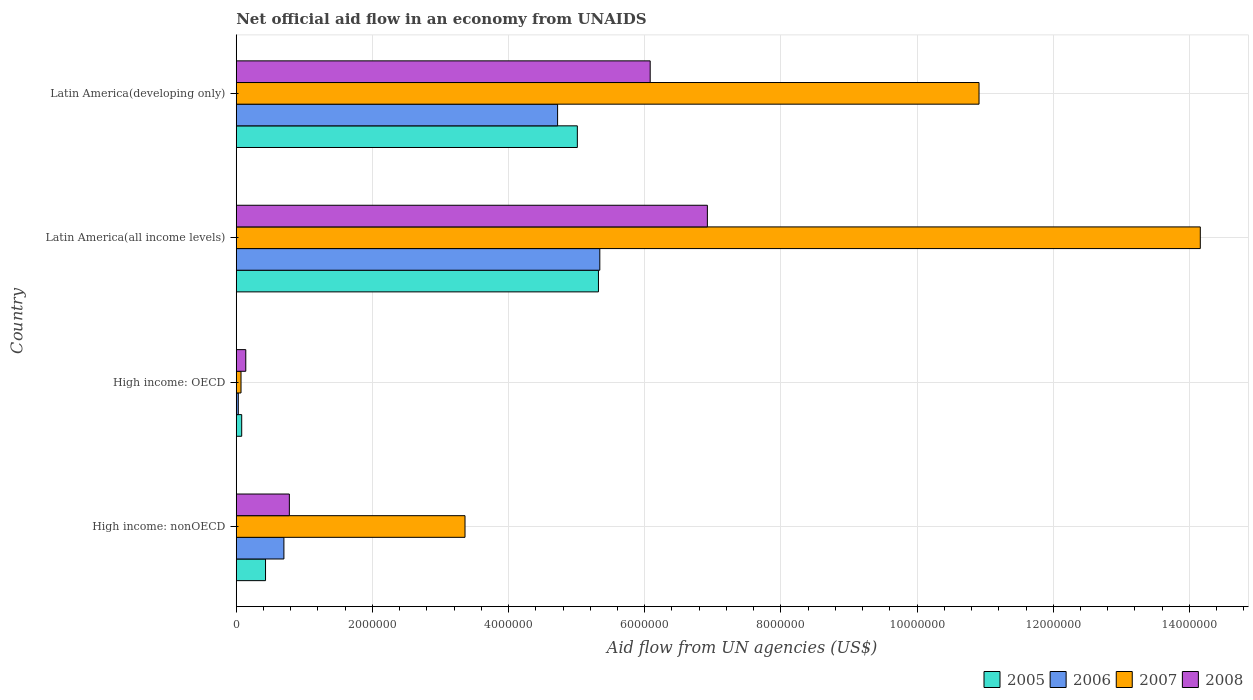Are the number of bars on each tick of the Y-axis equal?
Your answer should be very brief. Yes. What is the label of the 2nd group of bars from the top?
Ensure brevity in your answer.  Latin America(all income levels). In how many cases, is the number of bars for a given country not equal to the number of legend labels?
Your answer should be very brief. 0. What is the net official aid flow in 2008 in High income: nonOECD?
Offer a very short reply. 7.80e+05. Across all countries, what is the maximum net official aid flow in 2005?
Give a very brief answer. 5.32e+06. In which country was the net official aid flow in 2005 maximum?
Your response must be concise. Latin America(all income levels). In which country was the net official aid flow in 2005 minimum?
Ensure brevity in your answer.  High income: OECD. What is the total net official aid flow in 2007 in the graph?
Ensure brevity in your answer.  2.85e+07. What is the difference between the net official aid flow in 2005 in Latin America(all income levels) and that in Latin America(developing only)?
Make the answer very short. 3.10e+05. What is the difference between the net official aid flow in 2008 in Latin America(developing only) and the net official aid flow in 2006 in High income: nonOECD?
Give a very brief answer. 5.38e+06. What is the average net official aid flow in 2007 per country?
Keep it short and to the point. 7.12e+06. What is the difference between the net official aid flow in 2006 and net official aid flow in 2007 in Latin America(developing only)?
Your response must be concise. -6.19e+06. In how many countries, is the net official aid flow in 2008 greater than 2800000 US$?
Give a very brief answer. 2. What is the ratio of the net official aid flow in 2005 in High income: nonOECD to that in Latin America(developing only)?
Keep it short and to the point. 0.09. Is the net official aid flow in 2006 in High income: OECD less than that in High income: nonOECD?
Provide a succinct answer. Yes. What is the difference between the highest and the second highest net official aid flow in 2008?
Make the answer very short. 8.40e+05. What is the difference between the highest and the lowest net official aid flow in 2008?
Your answer should be compact. 6.78e+06. What does the 4th bar from the bottom in High income: OECD represents?
Your answer should be very brief. 2008. Is it the case that in every country, the sum of the net official aid flow in 2005 and net official aid flow in 2006 is greater than the net official aid flow in 2007?
Offer a terse response. No. How many bars are there?
Your response must be concise. 16. Are all the bars in the graph horizontal?
Offer a very short reply. Yes. How many countries are there in the graph?
Offer a terse response. 4. What is the difference between two consecutive major ticks on the X-axis?
Offer a terse response. 2.00e+06. Does the graph contain any zero values?
Your answer should be compact. No. How many legend labels are there?
Keep it short and to the point. 4. How are the legend labels stacked?
Your answer should be very brief. Horizontal. What is the title of the graph?
Provide a short and direct response. Net official aid flow in an economy from UNAIDS. Does "1995" appear as one of the legend labels in the graph?
Your answer should be compact. No. What is the label or title of the X-axis?
Provide a short and direct response. Aid flow from UN agencies (US$). What is the label or title of the Y-axis?
Provide a succinct answer. Country. What is the Aid flow from UN agencies (US$) in 2005 in High income: nonOECD?
Ensure brevity in your answer.  4.30e+05. What is the Aid flow from UN agencies (US$) in 2007 in High income: nonOECD?
Give a very brief answer. 3.36e+06. What is the Aid flow from UN agencies (US$) of 2008 in High income: nonOECD?
Provide a succinct answer. 7.80e+05. What is the Aid flow from UN agencies (US$) of 2008 in High income: OECD?
Offer a very short reply. 1.40e+05. What is the Aid flow from UN agencies (US$) in 2005 in Latin America(all income levels)?
Provide a short and direct response. 5.32e+06. What is the Aid flow from UN agencies (US$) in 2006 in Latin America(all income levels)?
Ensure brevity in your answer.  5.34e+06. What is the Aid flow from UN agencies (US$) in 2007 in Latin America(all income levels)?
Offer a terse response. 1.42e+07. What is the Aid flow from UN agencies (US$) in 2008 in Latin America(all income levels)?
Make the answer very short. 6.92e+06. What is the Aid flow from UN agencies (US$) of 2005 in Latin America(developing only)?
Your answer should be very brief. 5.01e+06. What is the Aid flow from UN agencies (US$) in 2006 in Latin America(developing only)?
Offer a terse response. 4.72e+06. What is the Aid flow from UN agencies (US$) of 2007 in Latin America(developing only)?
Your response must be concise. 1.09e+07. What is the Aid flow from UN agencies (US$) of 2008 in Latin America(developing only)?
Your answer should be very brief. 6.08e+06. Across all countries, what is the maximum Aid flow from UN agencies (US$) of 2005?
Your response must be concise. 5.32e+06. Across all countries, what is the maximum Aid flow from UN agencies (US$) in 2006?
Your answer should be very brief. 5.34e+06. Across all countries, what is the maximum Aid flow from UN agencies (US$) in 2007?
Give a very brief answer. 1.42e+07. Across all countries, what is the maximum Aid flow from UN agencies (US$) of 2008?
Give a very brief answer. 6.92e+06. Across all countries, what is the minimum Aid flow from UN agencies (US$) in 2005?
Ensure brevity in your answer.  8.00e+04. Across all countries, what is the minimum Aid flow from UN agencies (US$) in 2008?
Keep it short and to the point. 1.40e+05. What is the total Aid flow from UN agencies (US$) of 2005 in the graph?
Your answer should be very brief. 1.08e+07. What is the total Aid flow from UN agencies (US$) in 2006 in the graph?
Provide a succinct answer. 1.08e+07. What is the total Aid flow from UN agencies (US$) in 2007 in the graph?
Your answer should be very brief. 2.85e+07. What is the total Aid flow from UN agencies (US$) of 2008 in the graph?
Provide a succinct answer. 1.39e+07. What is the difference between the Aid flow from UN agencies (US$) of 2005 in High income: nonOECD and that in High income: OECD?
Provide a succinct answer. 3.50e+05. What is the difference between the Aid flow from UN agencies (US$) of 2006 in High income: nonOECD and that in High income: OECD?
Your response must be concise. 6.70e+05. What is the difference between the Aid flow from UN agencies (US$) of 2007 in High income: nonOECD and that in High income: OECD?
Give a very brief answer. 3.29e+06. What is the difference between the Aid flow from UN agencies (US$) of 2008 in High income: nonOECD and that in High income: OECD?
Keep it short and to the point. 6.40e+05. What is the difference between the Aid flow from UN agencies (US$) of 2005 in High income: nonOECD and that in Latin America(all income levels)?
Your response must be concise. -4.89e+06. What is the difference between the Aid flow from UN agencies (US$) in 2006 in High income: nonOECD and that in Latin America(all income levels)?
Your response must be concise. -4.64e+06. What is the difference between the Aid flow from UN agencies (US$) in 2007 in High income: nonOECD and that in Latin America(all income levels)?
Provide a short and direct response. -1.08e+07. What is the difference between the Aid flow from UN agencies (US$) of 2008 in High income: nonOECD and that in Latin America(all income levels)?
Give a very brief answer. -6.14e+06. What is the difference between the Aid flow from UN agencies (US$) of 2005 in High income: nonOECD and that in Latin America(developing only)?
Give a very brief answer. -4.58e+06. What is the difference between the Aid flow from UN agencies (US$) of 2006 in High income: nonOECD and that in Latin America(developing only)?
Keep it short and to the point. -4.02e+06. What is the difference between the Aid flow from UN agencies (US$) in 2007 in High income: nonOECD and that in Latin America(developing only)?
Offer a very short reply. -7.55e+06. What is the difference between the Aid flow from UN agencies (US$) of 2008 in High income: nonOECD and that in Latin America(developing only)?
Provide a succinct answer. -5.30e+06. What is the difference between the Aid flow from UN agencies (US$) in 2005 in High income: OECD and that in Latin America(all income levels)?
Ensure brevity in your answer.  -5.24e+06. What is the difference between the Aid flow from UN agencies (US$) in 2006 in High income: OECD and that in Latin America(all income levels)?
Make the answer very short. -5.31e+06. What is the difference between the Aid flow from UN agencies (US$) of 2007 in High income: OECD and that in Latin America(all income levels)?
Offer a terse response. -1.41e+07. What is the difference between the Aid flow from UN agencies (US$) in 2008 in High income: OECD and that in Latin America(all income levels)?
Your answer should be compact. -6.78e+06. What is the difference between the Aid flow from UN agencies (US$) in 2005 in High income: OECD and that in Latin America(developing only)?
Make the answer very short. -4.93e+06. What is the difference between the Aid flow from UN agencies (US$) of 2006 in High income: OECD and that in Latin America(developing only)?
Make the answer very short. -4.69e+06. What is the difference between the Aid flow from UN agencies (US$) in 2007 in High income: OECD and that in Latin America(developing only)?
Your answer should be compact. -1.08e+07. What is the difference between the Aid flow from UN agencies (US$) in 2008 in High income: OECD and that in Latin America(developing only)?
Make the answer very short. -5.94e+06. What is the difference between the Aid flow from UN agencies (US$) in 2006 in Latin America(all income levels) and that in Latin America(developing only)?
Your answer should be very brief. 6.20e+05. What is the difference between the Aid flow from UN agencies (US$) in 2007 in Latin America(all income levels) and that in Latin America(developing only)?
Ensure brevity in your answer.  3.25e+06. What is the difference between the Aid flow from UN agencies (US$) of 2008 in Latin America(all income levels) and that in Latin America(developing only)?
Provide a succinct answer. 8.40e+05. What is the difference between the Aid flow from UN agencies (US$) in 2005 in High income: nonOECD and the Aid flow from UN agencies (US$) in 2006 in High income: OECD?
Provide a short and direct response. 4.00e+05. What is the difference between the Aid flow from UN agencies (US$) of 2005 in High income: nonOECD and the Aid flow from UN agencies (US$) of 2008 in High income: OECD?
Your response must be concise. 2.90e+05. What is the difference between the Aid flow from UN agencies (US$) of 2006 in High income: nonOECD and the Aid flow from UN agencies (US$) of 2007 in High income: OECD?
Your answer should be very brief. 6.30e+05. What is the difference between the Aid flow from UN agencies (US$) in 2006 in High income: nonOECD and the Aid flow from UN agencies (US$) in 2008 in High income: OECD?
Provide a short and direct response. 5.60e+05. What is the difference between the Aid flow from UN agencies (US$) in 2007 in High income: nonOECD and the Aid flow from UN agencies (US$) in 2008 in High income: OECD?
Provide a short and direct response. 3.22e+06. What is the difference between the Aid flow from UN agencies (US$) in 2005 in High income: nonOECD and the Aid flow from UN agencies (US$) in 2006 in Latin America(all income levels)?
Make the answer very short. -4.91e+06. What is the difference between the Aid flow from UN agencies (US$) of 2005 in High income: nonOECD and the Aid flow from UN agencies (US$) of 2007 in Latin America(all income levels)?
Make the answer very short. -1.37e+07. What is the difference between the Aid flow from UN agencies (US$) in 2005 in High income: nonOECD and the Aid flow from UN agencies (US$) in 2008 in Latin America(all income levels)?
Provide a succinct answer. -6.49e+06. What is the difference between the Aid flow from UN agencies (US$) in 2006 in High income: nonOECD and the Aid flow from UN agencies (US$) in 2007 in Latin America(all income levels)?
Make the answer very short. -1.35e+07. What is the difference between the Aid flow from UN agencies (US$) of 2006 in High income: nonOECD and the Aid flow from UN agencies (US$) of 2008 in Latin America(all income levels)?
Your answer should be compact. -6.22e+06. What is the difference between the Aid flow from UN agencies (US$) of 2007 in High income: nonOECD and the Aid flow from UN agencies (US$) of 2008 in Latin America(all income levels)?
Make the answer very short. -3.56e+06. What is the difference between the Aid flow from UN agencies (US$) of 2005 in High income: nonOECD and the Aid flow from UN agencies (US$) of 2006 in Latin America(developing only)?
Offer a terse response. -4.29e+06. What is the difference between the Aid flow from UN agencies (US$) in 2005 in High income: nonOECD and the Aid flow from UN agencies (US$) in 2007 in Latin America(developing only)?
Offer a terse response. -1.05e+07. What is the difference between the Aid flow from UN agencies (US$) in 2005 in High income: nonOECD and the Aid flow from UN agencies (US$) in 2008 in Latin America(developing only)?
Offer a very short reply. -5.65e+06. What is the difference between the Aid flow from UN agencies (US$) in 2006 in High income: nonOECD and the Aid flow from UN agencies (US$) in 2007 in Latin America(developing only)?
Offer a terse response. -1.02e+07. What is the difference between the Aid flow from UN agencies (US$) in 2006 in High income: nonOECD and the Aid flow from UN agencies (US$) in 2008 in Latin America(developing only)?
Keep it short and to the point. -5.38e+06. What is the difference between the Aid flow from UN agencies (US$) in 2007 in High income: nonOECD and the Aid flow from UN agencies (US$) in 2008 in Latin America(developing only)?
Make the answer very short. -2.72e+06. What is the difference between the Aid flow from UN agencies (US$) of 2005 in High income: OECD and the Aid flow from UN agencies (US$) of 2006 in Latin America(all income levels)?
Provide a short and direct response. -5.26e+06. What is the difference between the Aid flow from UN agencies (US$) in 2005 in High income: OECD and the Aid flow from UN agencies (US$) in 2007 in Latin America(all income levels)?
Ensure brevity in your answer.  -1.41e+07. What is the difference between the Aid flow from UN agencies (US$) in 2005 in High income: OECD and the Aid flow from UN agencies (US$) in 2008 in Latin America(all income levels)?
Your response must be concise. -6.84e+06. What is the difference between the Aid flow from UN agencies (US$) in 2006 in High income: OECD and the Aid flow from UN agencies (US$) in 2007 in Latin America(all income levels)?
Your answer should be compact. -1.41e+07. What is the difference between the Aid flow from UN agencies (US$) in 2006 in High income: OECD and the Aid flow from UN agencies (US$) in 2008 in Latin America(all income levels)?
Keep it short and to the point. -6.89e+06. What is the difference between the Aid flow from UN agencies (US$) in 2007 in High income: OECD and the Aid flow from UN agencies (US$) in 2008 in Latin America(all income levels)?
Your response must be concise. -6.85e+06. What is the difference between the Aid flow from UN agencies (US$) in 2005 in High income: OECD and the Aid flow from UN agencies (US$) in 2006 in Latin America(developing only)?
Provide a succinct answer. -4.64e+06. What is the difference between the Aid flow from UN agencies (US$) of 2005 in High income: OECD and the Aid flow from UN agencies (US$) of 2007 in Latin America(developing only)?
Give a very brief answer. -1.08e+07. What is the difference between the Aid flow from UN agencies (US$) of 2005 in High income: OECD and the Aid flow from UN agencies (US$) of 2008 in Latin America(developing only)?
Your response must be concise. -6.00e+06. What is the difference between the Aid flow from UN agencies (US$) of 2006 in High income: OECD and the Aid flow from UN agencies (US$) of 2007 in Latin America(developing only)?
Give a very brief answer. -1.09e+07. What is the difference between the Aid flow from UN agencies (US$) of 2006 in High income: OECD and the Aid flow from UN agencies (US$) of 2008 in Latin America(developing only)?
Ensure brevity in your answer.  -6.05e+06. What is the difference between the Aid flow from UN agencies (US$) of 2007 in High income: OECD and the Aid flow from UN agencies (US$) of 2008 in Latin America(developing only)?
Provide a short and direct response. -6.01e+06. What is the difference between the Aid flow from UN agencies (US$) of 2005 in Latin America(all income levels) and the Aid flow from UN agencies (US$) of 2007 in Latin America(developing only)?
Your answer should be very brief. -5.59e+06. What is the difference between the Aid flow from UN agencies (US$) in 2005 in Latin America(all income levels) and the Aid flow from UN agencies (US$) in 2008 in Latin America(developing only)?
Make the answer very short. -7.60e+05. What is the difference between the Aid flow from UN agencies (US$) in 2006 in Latin America(all income levels) and the Aid flow from UN agencies (US$) in 2007 in Latin America(developing only)?
Make the answer very short. -5.57e+06. What is the difference between the Aid flow from UN agencies (US$) of 2006 in Latin America(all income levels) and the Aid flow from UN agencies (US$) of 2008 in Latin America(developing only)?
Provide a short and direct response. -7.40e+05. What is the difference between the Aid flow from UN agencies (US$) in 2007 in Latin America(all income levels) and the Aid flow from UN agencies (US$) in 2008 in Latin America(developing only)?
Provide a short and direct response. 8.08e+06. What is the average Aid flow from UN agencies (US$) of 2005 per country?
Offer a very short reply. 2.71e+06. What is the average Aid flow from UN agencies (US$) in 2006 per country?
Your answer should be compact. 2.70e+06. What is the average Aid flow from UN agencies (US$) of 2007 per country?
Your answer should be compact. 7.12e+06. What is the average Aid flow from UN agencies (US$) in 2008 per country?
Provide a succinct answer. 3.48e+06. What is the difference between the Aid flow from UN agencies (US$) in 2005 and Aid flow from UN agencies (US$) in 2006 in High income: nonOECD?
Provide a succinct answer. -2.70e+05. What is the difference between the Aid flow from UN agencies (US$) in 2005 and Aid flow from UN agencies (US$) in 2007 in High income: nonOECD?
Offer a terse response. -2.93e+06. What is the difference between the Aid flow from UN agencies (US$) of 2005 and Aid flow from UN agencies (US$) of 2008 in High income: nonOECD?
Your answer should be compact. -3.50e+05. What is the difference between the Aid flow from UN agencies (US$) in 2006 and Aid flow from UN agencies (US$) in 2007 in High income: nonOECD?
Offer a terse response. -2.66e+06. What is the difference between the Aid flow from UN agencies (US$) of 2007 and Aid flow from UN agencies (US$) of 2008 in High income: nonOECD?
Your answer should be compact. 2.58e+06. What is the difference between the Aid flow from UN agencies (US$) in 2005 and Aid flow from UN agencies (US$) in 2006 in High income: OECD?
Provide a succinct answer. 5.00e+04. What is the difference between the Aid flow from UN agencies (US$) in 2006 and Aid flow from UN agencies (US$) in 2007 in High income: OECD?
Your answer should be very brief. -4.00e+04. What is the difference between the Aid flow from UN agencies (US$) of 2007 and Aid flow from UN agencies (US$) of 2008 in High income: OECD?
Ensure brevity in your answer.  -7.00e+04. What is the difference between the Aid flow from UN agencies (US$) in 2005 and Aid flow from UN agencies (US$) in 2007 in Latin America(all income levels)?
Provide a short and direct response. -8.84e+06. What is the difference between the Aid flow from UN agencies (US$) in 2005 and Aid flow from UN agencies (US$) in 2008 in Latin America(all income levels)?
Provide a short and direct response. -1.60e+06. What is the difference between the Aid flow from UN agencies (US$) of 2006 and Aid flow from UN agencies (US$) of 2007 in Latin America(all income levels)?
Make the answer very short. -8.82e+06. What is the difference between the Aid flow from UN agencies (US$) in 2006 and Aid flow from UN agencies (US$) in 2008 in Latin America(all income levels)?
Give a very brief answer. -1.58e+06. What is the difference between the Aid flow from UN agencies (US$) of 2007 and Aid flow from UN agencies (US$) of 2008 in Latin America(all income levels)?
Make the answer very short. 7.24e+06. What is the difference between the Aid flow from UN agencies (US$) in 2005 and Aid flow from UN agencies (US$) in 2006 in Latin America(developing only)?
Your answer should be compact. 2.90e+05. What is the difference between the Aid flow from UN agencies (US$) in 2005 and Aid flow from UN agencies (US$) in 2007 in Latin America(developing only)?
Make the answer very short. -5.90e+06. What is the difference between the Aid flow from UN agencies (US$) of 2005 and Aid flow from UN agencies (US$) of 2008 in Latin America(developing only)?
Provide a succinct answer. -1.07e+06. What is the difference between the Aid flow from UN agencies (US$) of 2006 and Aid flow from UN agencies (US$) of 2007 in Latin America(developing only)?
Provide a succinct answer. -6.19e+06. What is the difference between the Aid flow from UN agencies (US$) in 2006 and Aid flow from UN agencies (US$) in 2008 in Latin America(developing only)?
Provide a short and direct response. -1.36e+06. What is the difference between the Aid flow from UN agencies (US$) of 2007 and Aid flow from UN agencies (US$) of 2008 in Latin America(developing only)?
Provide a short and direct response. 4.83e+06. What is the ratio of the Aid flow from UN agencies (US$) in 2005 in High income: nonOECD to that in High income: OECD?
Offer a very short reply. 5.38. What is the ratio of the Aid flow from UN agencies (US$) in 2006 in High income: nonOECD to that in High income: OECD?
Your answer should be very brief. 23.33. What is the ratio of the Aid flow from UN agencies (US$) in 2008 in High income: nonOECD to that in High income: OECD?
Provide a short and direct response. 5.57. What is the ratio of the Aid flow from UN agencies (US$) of 2005 in High income: nonOECD to that in Latin America(all income levels)?
Your answer should be compact. 0.08. What is the ratio of the Aid flow from UN agencies (US$) in 2006 in High income: nonOECD to that in Latin America(all income levels)?
Your response must be concise. 0.13. What is the ratio of the Aid flow from UN agencies (US$) of 2007 in High income: nonOECD to that in Latin America(all income levels)?
Ensure brevity in your answer.  0.24. What is the ratio of the Aid flow from UN agencies (US$) in 2008 in High income: nonOECD to that in Latin America(all income levels)?
Give a very brief answer. 0.11. What is the ratio of the Aid flow from UN agencies (US$) in 2005 in High income: nonOECD to that in Latin America(developing only)?
Offer a terse response. 0.09. What is the ratio of the Aid flow from UN agencies (US$) in 2006 in High income: nonOECD to that in Latin America(developing only)?
Offer a terse response. 0.15. What is the ratio of the Aid flow from UN agencies (US$) in 2007 in High income: nonOECD to that in Latin America(developing only)?
Your response must be concise. 0.31. What is the ratio of the Aid flow from UN agencies (US$) in 2008 in High income: nonOECD to that in Latin America(developing only)?
Make the answer very short. 0.13. What is the ratio of the Aid flow from UN agencies (US$) in 2005 in High income: OECD to that in Latin America(all income levels)?
Provide a short and direct response. 0.01. What is the ratio of the Aid flow from UN agencies (US$) in 2006 in High income: OECD to that in Latin America(all income levels)?
Your response must be concise. 0.01. What is the ratio of the Aid flow from UN agencies (US$) of 2007 in High income: OECD to that in Latin America(all income levels)?
Ensure brevity in your answer.  0. What is the ratio of the Aid flow from UN agencies (US$) in 2008 in High income: OECD to that in Latin America(all income levels)?
Keep it short and to the point. 0.02. What is the ratio of the Aid flow from UN agencies (US$) in 2005 in High income: OECD to that in Latin America(developing only)?
Give a very brief answer. 0.02. What is the ratio of the Aid flow from UN agencies (US$) in 2006 in High income: OECD to that in Latin America(developing only)?
Provide a short and direct response. 0.01. What is the ratio of the Aid flow from UN agencies (US$) of 2007 in High income: OECD to that in Latin America(developing only)?
Provide a succinct answer. 0.01. What is the ratio of the Aid flow from UN agencies (US$) of 2008 in High income: OECD to that in Latin America(developing only)?
Ensure brevity in your answer.  0.02. What is the ratio of the Aid flow from UN agencies (US$) in 2005 in Latin America(all income levels) to that in Latin America(developing only)?
Provide a short and direct response. 1.06. What is the ratio of the Aid flow from UN agencies (US$) of 2006 in Latin America(all income levels) to that in Latin America(developing only)?
Keep it short and to the point. 1.13. What is the ratio of the Aid flow from UN agencies (US$) of 2007 in Latin America(all income levels) to that in Latin America(developing only)?
Your answer should be very brief. 1.3. What is the ratio of the Aid flow from UN agencies (US$) in 2008 in Latin America(all income levels) to that in Latin America(developing only)?
Give a very brief answer. 1.14. What is the difference between the highest and the second highest Aid flow from UN agencies (US$) in 2005?
Give a very brief answer. 3.10e+05. What is the difference between the highest and the second highest Aid flow from UN agencies (US$) of 2006?
Offer a very short reply. 6.20e+05. What is the difference between the highest and the second highest Aid flow from UN agencies (US$) of 2007?
Your response must be concise. 3.25e+06. What is the difference between the highest and the second highest Aid flow from UN agencies (US$) of 2008?
Ensure brevity in your answer.  8.40e+05. What is the difference between the highest and the lowest Aid flow from UN agencies (US$) in 2005?
Your answer should be very brief. 5.24e+06. What is the difference between the highest and the lowest Aid flow from UN agencies (US$) of 2006?
Offer a terse response. 5.31e+06. What is the difference between the highest and the lowest Aid flow from UN agencies (US$) in 2007?
Offer a very short reply. 1.41e+07. What is the difference between the highest and the lowest Aid flow from UN agencies (US$) in 2008?
Offer a very short reply. 6.78e+06. 